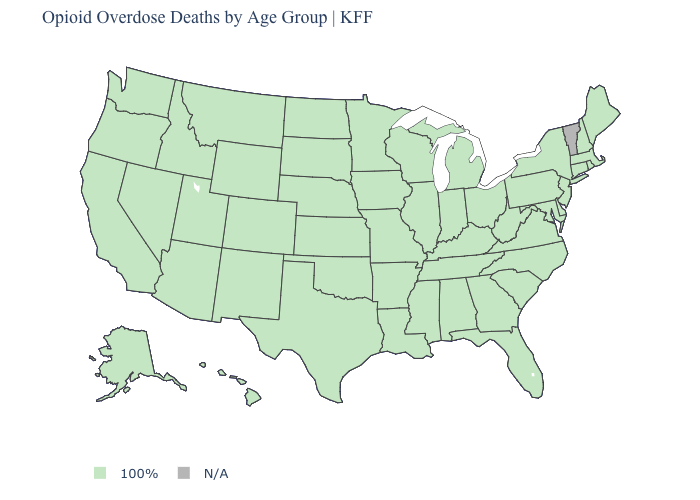Name the states that have a value in the range N/A?
Quick response, please. Vermont. What is the value of Missouri?
Quick response, please. 100%. Which states have the lowest value in the USA?
Concise answer only. Alabama, Alaska, Arizona, Arkansas, California, Colorado, Connecticut, Delaware, Florida, Georgia, Hawaii, Idaho, Illinois, Indiana, Iowa, Kansas, Kentucky, Louisiana, Maine, Maryland, Massachusetts, Michigan, Minnesota, Mississippi, Missouri, Montana, Nebraska, Nevada, New Hampshire, New Jersey, New Mexico, New York, North Carolina, North Dakota, Ohio, Oklahoma, Oregon, Pennsylvania, Rhode Island, South Carolina, South Dakota, Tennessee, Texas, Utah, Virginia, Washington, West Virginia, Wisconsin, Wyoming. Among the states that border Texas , which have the highest value?
Concise answer only. Arkansas, Louisiana, New Mexico, Oklahoma. What is the highest value in states that border Arizona?
Quick response, please. 100%. What is the value of Connecticut?
Concise answer only. 100%. Name the states that have a value in the range 100%?
Write a very short answer. Alabama, Alaska, Arizona, Arkansas, California, Colorado, Connecticut, Delaware, Florida, Georgia, Hawaii, Idaho, Illinois, Indiana, Iowa, Kansas, Kentucky, Louisiana, Maine, Maryland, Massachusetts, Michigan, Minnesota, Mississippi, Missouri, Montana, Nebraska, Nevada, New Hampshire, New Jersey, New Mexico, New York, North Carolina, North Dakota, Ohio, Oklahoma, Oregon, Pennsylvania, Rhode Island, South Carolina, South Dakota, Tennessee, Texas, Utah, Virginia, Washington, West Virginia, Wisconsin, Wyoming. What is the value of Colorado?
Be succinct. 100%. Name the states that have a value in the range 100%?
Concise answer only. Alabama, Alaska, Arizona, Arkansas, California, Colorado, Connecticut, Delaware, Florida, Georgia, Hawaii, Idaho, Illinois, Indiana, Iowa, Kansas, Kentucky, Louisiana, Maine, Maryland, Massachusetts, Michigan, Minnesota, Mississippi, Missouri, Montana, Nebraska, Nevada, New Hampshire, New Jersey, New Mexico, New York, North Carolina, North Dakota, Ohio, Oklahoma, Oregon, Pennsylvania, Rhode Island, South Carolina, South Dakota, Tennessee, Texas, Utah, Virginia, Washington, West Virginia, Wisconsin, Wyoming. What is the lowest value in states that border West Virginia?
Be succinct. 100%. Which states have the lowest value in the USA?
Answer briefly. Alabama, Alaska, Arizona, Arkansas, California, Colorado, Connecticut, Delaware, Florida, Georgia, Hawaii, Idaho, Illinois, Indiana, Iowa, Kansas, Kentucky, Louisiana, Maine, Maryland, Massachusetts, Michigan, Minnesota, Mississippi, Missouri, Montana, Nebraska, Nevada, New Hampshire, New Jersey, New Mexico, New York, North Carolina, North Dakota, Ohio, Oklahoma, Oregon, Pennsylvania, Rhode Island, South Carolina, South Dakota, Tennessee, Texas, Utah, Virginia, Washington, West Virginia, Wisconsin, Wyoming. Name the states that have a value in the range N/A?
Answer briefly. Vermont. 